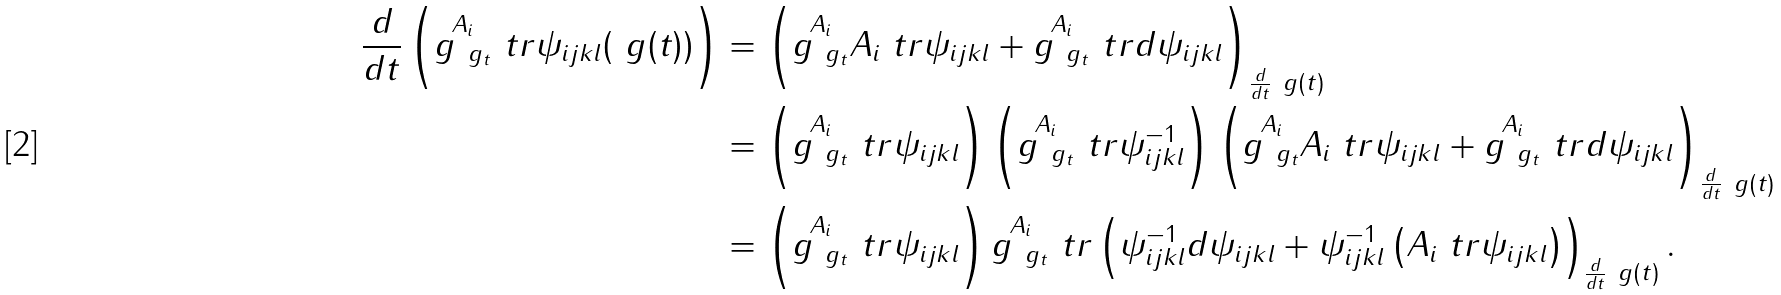<formula> <loc_0><loc_0><loc_500><loc_500>\frac { d } { d t } \left ( { \stackrel { A _ { i } } { g _ { \ g _ { t } } } } \ t r \psi _ { i j k l } ( \ g ( t ) ) \right ) & = \left ( { \stackrel { A _ { i } } { g _ { \ g _ { t } } } } A _ { i } \ t r \psi _ { i j k l } + { \stackrel { A _ { i } } { g _ { \ g _ { t } } } } \ t r d \psi _ { i j k l } \right ) _ { \frac { d } { d t } \ g ( t ) } \\ & = \left ( { \stackrel { A _ { i } } { g _ { \ g _ { t } } } } \ t r \psi _ { i j k l } \right ) \left ( { \stackrel { A _ { i } } { g _ { \ g _ { t } } } } \ t r \psi _ { i j k l } ^ { - 1 } \right ) \left ( { \stackrel { A _ { i } } { g _ { \ g _ { t } } } } A _ { i } \ t r \psi _ { i j k l } + { \stackrel { A _ { i } } { g _ { \ g _ { t } } } } \ t r d \psi _ { i j k l } \right ) _ { \frac { d } { d t } \ g ( t ) } \\ & = \left ( { \stackrel { A _ { i } } { g _ { \ g _ { t } } } } \ t r \psi _ { i j k l } \right ) { \stackrel { A _ { i } } { g _ { \ g _ { t } } } } \ t r \left ( \psi _ { i j k l } ^ { - 1 } d \psi _ { i j k l } + \psi _ { i j k l } ^ { - 1 } \left ( A _ { i } \ t r \psi _ { i j k l } \right ) \right ) _ { \frac { d } { d t } \ g ( t ) } .</formula> 